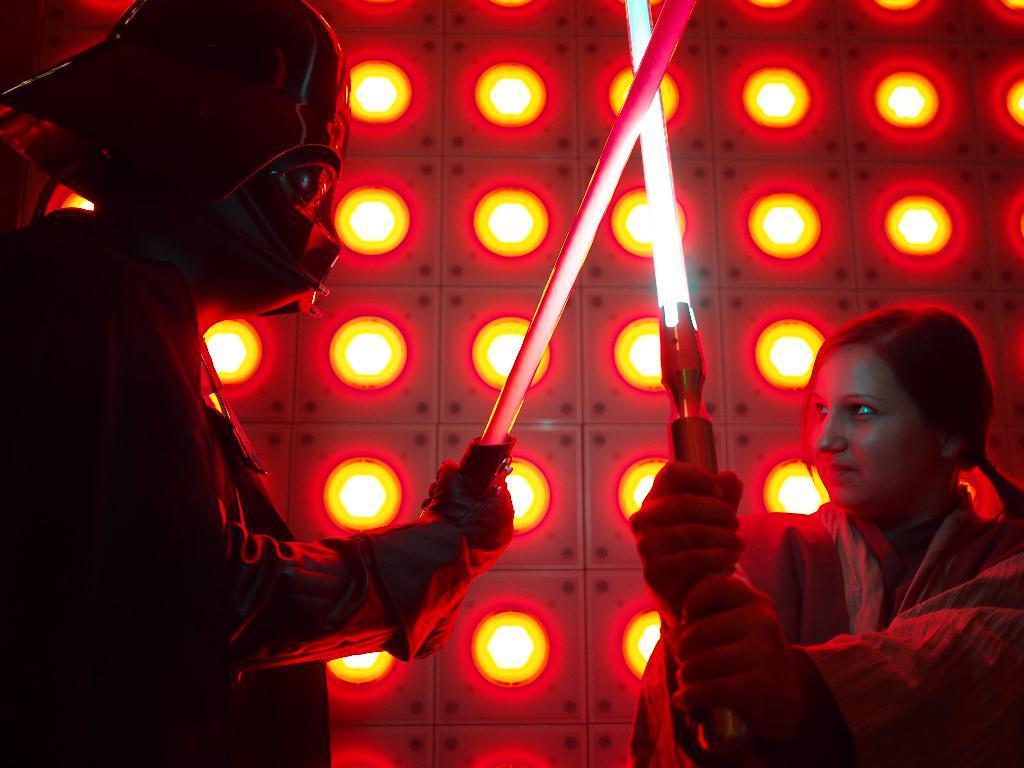Describe this image in one or two sentences. On the right side I can see a woman and on the left side I can see a person wearing jacket and mask to the head. Both are holding swords in the hands and looking at each other. In the background, I can see few lights. 